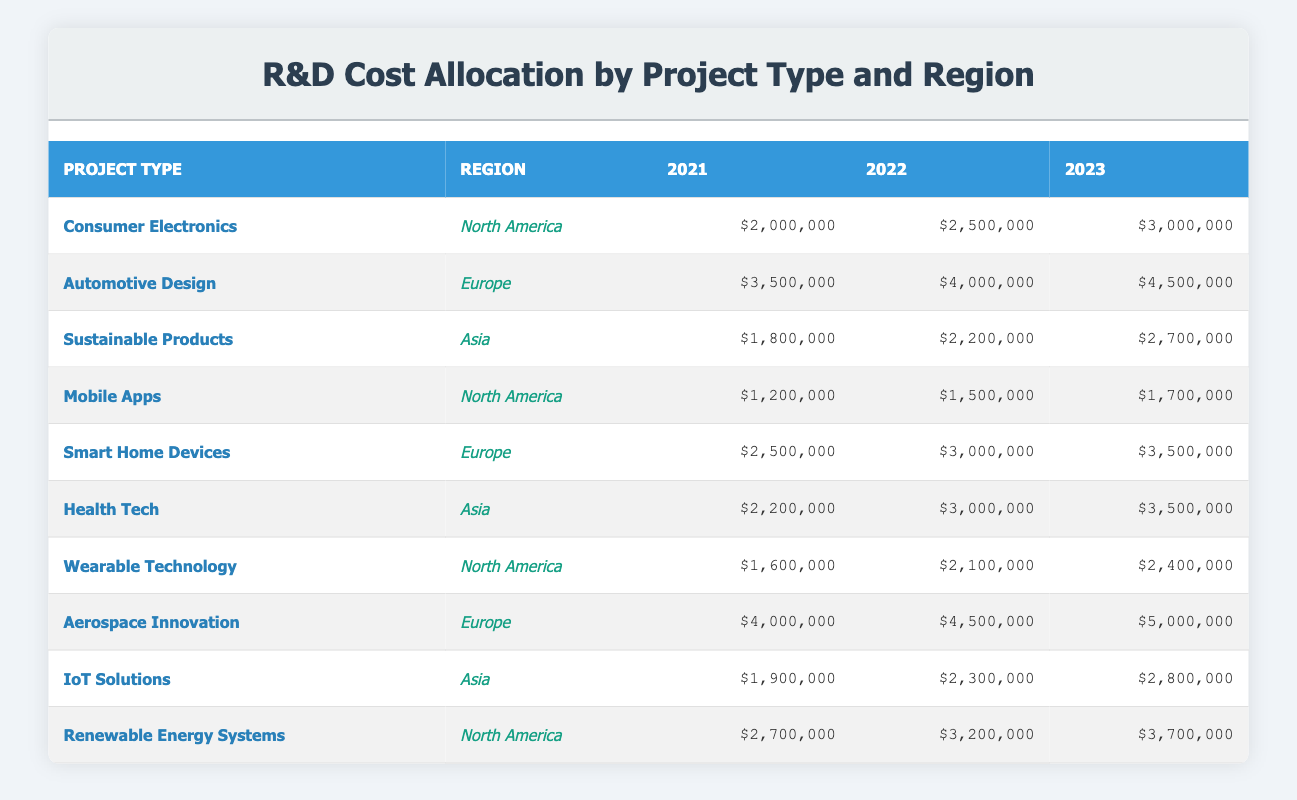What was the R&D cost allocation for Consumer Electronics in North America in 2022? The table lists the R&D cost for Consumer Electronics in North America for the year 2022 as $2,500,000.
Answer: $2,500,000 Which project type had the highest R&D cost in 2021? Looking at the 2021 column, Aerospace Innovation has the highest R&D cost listed at $4,000,000 compared to other projects.
Answer: Aerospace Innovation What is the total R&D cost allocation for Renewable Energy Systems over the three years? Summing the costs for Renewable Energy Systems: $2,700,000 (2021) + $3,200,000 (2022) + $3,700,000 (2023) equals $9,600,000.
Answer: $9,600,000 Did the R&D cost for Health Tech increase every year? Health Tech shows a cost of $2,200,000 in 2021, $3,000,000 in 2022, and $3,500,000 in 2023. Since each subsequent year shows higher costs, the statement is true.
Answer: Yes What is the average R&D cost allocation for Mobile Apps over the years? The costs for Mobile Apps are $1,200,000 (2021), $1,500,000 (2022), and $1,700,000 (2023). Summing these gives $4,400,000, divided by 3 (the number of years) equals approximately $1,466,667.
Answer: $1,466,667 In which region was Sustainable Products project located? The table indicates that Sustainable Products is categorized under Asia region.
Answer: Asia What is the difference in R&D costs for Smart Home Devices between 2021 and 2023? The R&D cost for Smart Home Devices in 2021 is $2,500,000 and in 2023 it is $3,500,000. The difference is $3,500,000 - $2,500,000 which equals $1,000,000.
Answer: $1,000,000 For which project type in Europe was the R&D cost allocation the highest in 2023 and what was that amount? In the 2023 column for Europe, Aerospace Innovation has the highest allocation at $5,000,000, compared to other project types listed.
Answer: Aerospace Innovation, $5,000,000 How much R&D cost did North America allocate for Wearable Technology in 2022 compared to 2023? The allocation for Wearable Technology is $2,100,000 in 2022 and $2,400,000 in 2023. The values are close, however, 2023 is higher by $300,000.
Answer: 2022: $2,100,000, 2023: $2,400,000 What was the total cost of R&D for the Asia region in 2021? The Asia region consists of Sustainable Products ($1,800,000), Health Tech ($2,200,000), and IoT Solutions ($1,900,000). Adding these gives a total: $1,800,000 + $2,200,000 + $1,900,000 = $5,900,000.
Answer: $5,900,000 